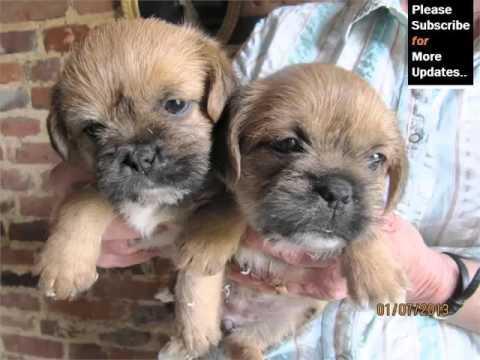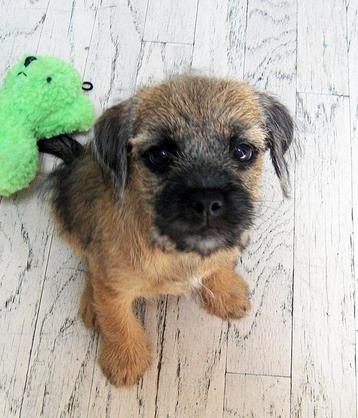The first image is the image on the left, the second image is the image on the right. For the images shown, is this caption "An image contains two dogs with their heads touching each other." true? Answer yes or no. Yes. 